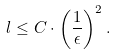Convert formula to latex. <formula><loc_0><loc_0><loc_500><loc_500>l \leq C \cdot \left ( \frac { 1 } { \epsilon } \right ) ^ { 2 } .</formula> 